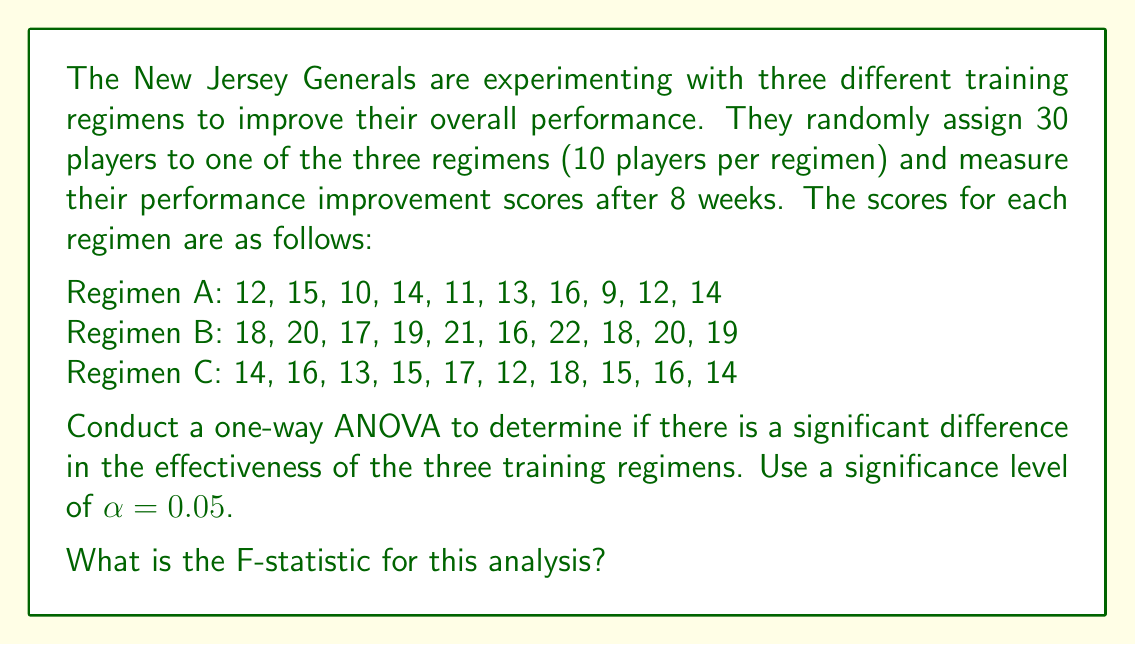Give your solution to this math problem. To conduct a one-way ANOVA, we'll follow these steps:

1. Calculate the sum of squares between groups (SSB)
2. Calculate the sum of squares within groups (SSW)
3. Calculate the total sum of squares (SST)
4. Determine the degrees of freedom
5. Calculate the mean squares
6. Compute the F-statistic

Step 1: Calculate SSB

First, we need to find the grand mean and group means:

Grand mean: $\bar{X} = \frac{390}{30} = 13$

Group means:
Regimen A: $\bar{X}_A = \frac{126}{10} = 12.6$
Regimen B: $\bar{X}_B = \frac{190}{10} = 19$
Regimen C: $\bar{X}_C = \frac{150}{10} = 15$

Now, we can calculate SSB:

$$SSB = \sum_{i=1}^{k} n_i(\bar{X}_i - \bar{X})^2$$

$$SSB = 10(12.6 - 13)^2 + 10(19 - 13)^2 + 10(15 - 13)^2$$
$$SSB = 10(0.16) + 10(36) + 10(4) = 401.6$$

Step 2: Calculate SSW

$$SSW = \sum_{i=1}^{k} \sum_{j=1}^{n_i} (X_{ij} - \bar{X}_i)^2$$

Regimen A: $SSW_A = 42.4$
Regimen B: $SSW_B = 30$
Regimen C: $SSW_C = 32$

$$SSW = 42.4 + 30 + 32 = 104.4$$

Step 3: Calculate SST

$$SST = SSB + SSW = 401.6 + 104.4 = 506$$

Step 4: Determine degrees of freedom

Between groups: $df_B = k - 1 = 3 - 1 = 2$
Within groups: $df_W = N - k = 30 - 3 = 27$
Total: $df_T = N - 1 = 30 - 1 = 29$

Step 5: Calculate mean squares

$$MSB = \frac{SSB}{df_B} = \frac{401.6}{2} = 200.8$$
$$MSW = \frac{SSW}{df_W} = \frac{104.4}{27} = 3.867$$

Step 6: Compute the F-statistic

$$F = \frac{MSB}{MSW} = \frac{200.8}{3.867} = 51.93$$
Answer: The F-statistic for this analysis is 51.93. 